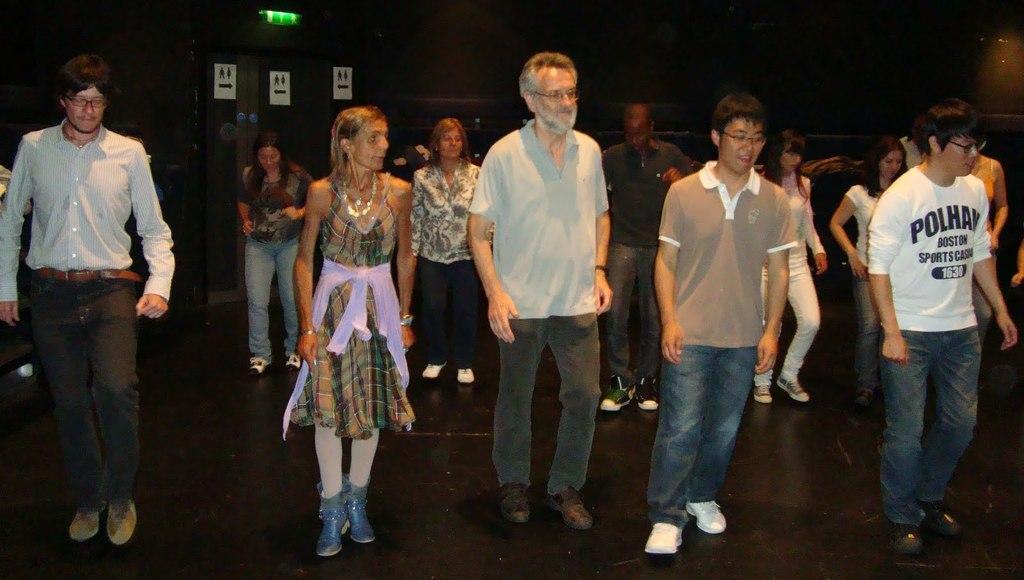How would you summarize this image in a sentence or two? In this picture there are people on the floor. In the background of the image it is dark and we can see boards. 